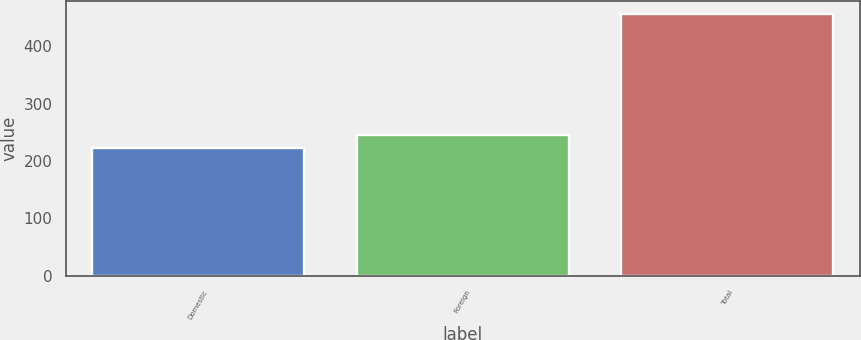Convert chart. <chart><loc_0><loc_0><loc_500><loc_500><bar_chart><fcel>Domestic<fcel>Foreign<fcel>Total<nl><fcel>221.8<fcel>245.22<fcel>456<nl></chart> 